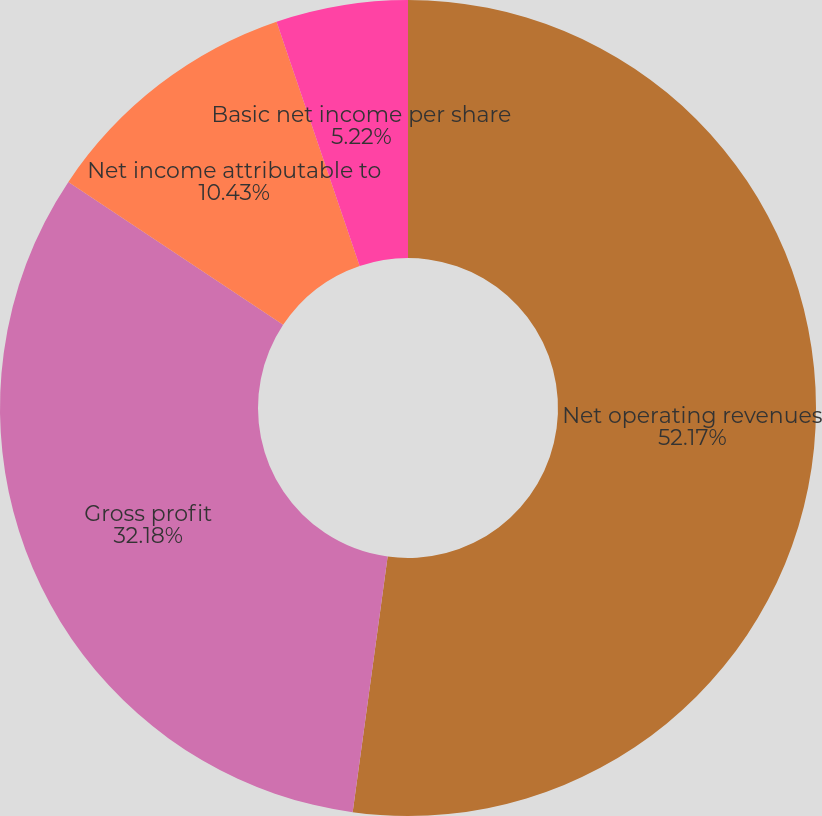Convert chart. <chart><loc_0><loc_0><loc_500><loc_500><pie_chart><fcel>Net operating revenues<fcel>Gross profit<fcel>Net income attributable to<fcel>Basic net income per share<fcel>Diluted net income per share<nl><fcel>52.16%<fcel>32.18%<fcel>10.43%<fcel>5.22%<fcel>0.0%<nl></chart> 